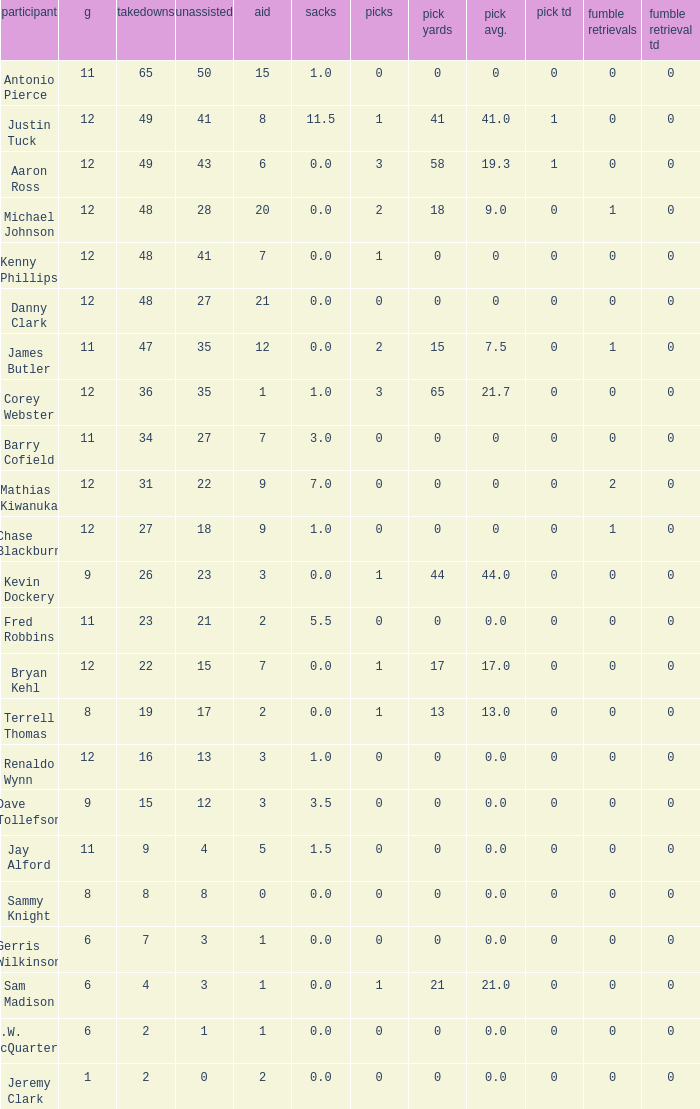Identify the smallest quantity of tackles for danny clark. 48.0. 